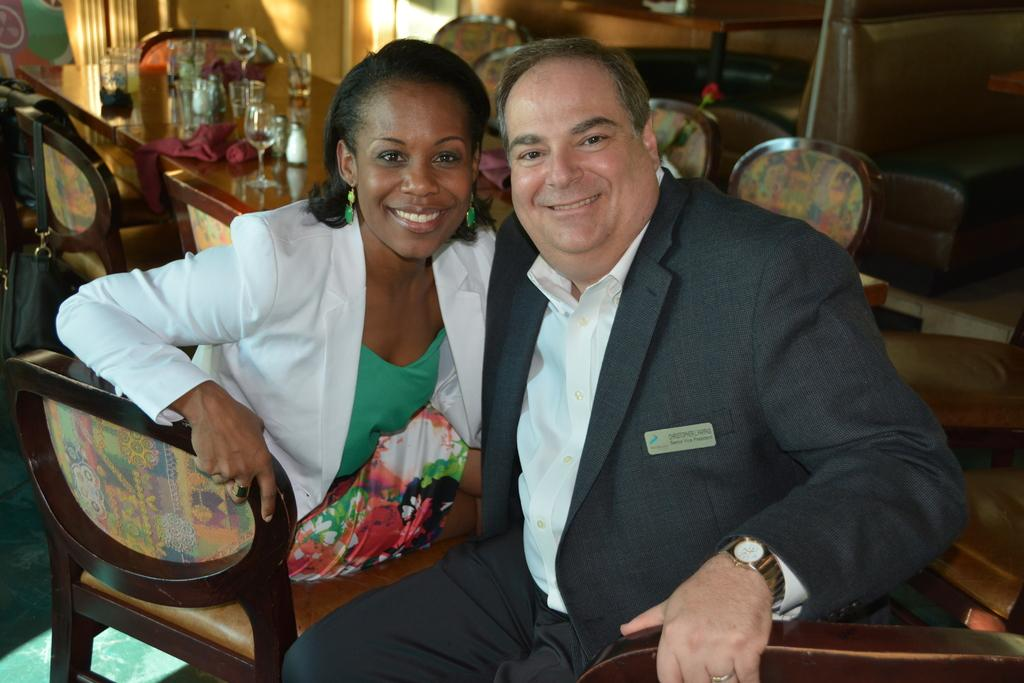Who can be seen in the image? There is a man and a woman in the image. What are the man and woman doing in the image? Both the man and woman are sitting on chairs. What can be seen in the background of the image? There is a wall and a table with glass items in the background. What type of belief can be seen in the image? There is no belief present in the image; it features a man and a woman sitting on chairs with a background of a wall and a table with glass items. Can you tell me how many mines are visible in the image? There are no mines present in the image. 